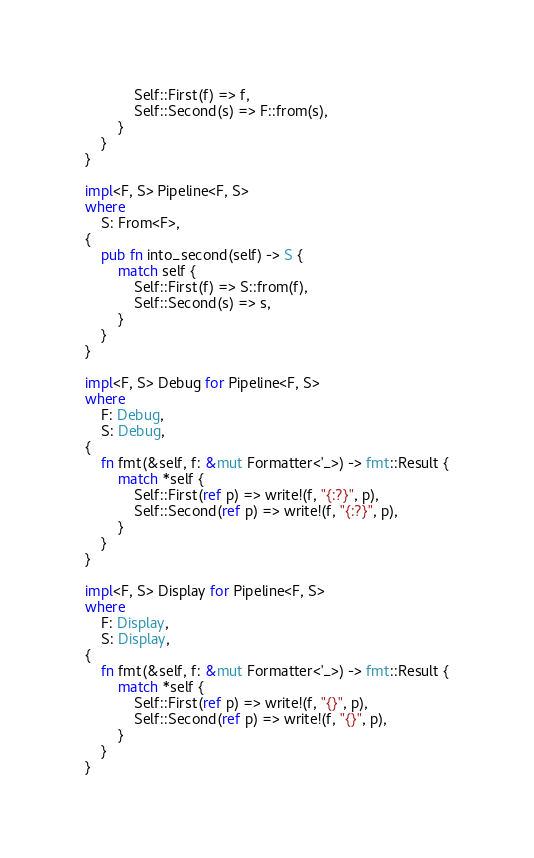<code> <loc_0><loc_0><loc_500><loc_500><_Rust_>            Self::First(f) => f,
            Self::Second(s) => F::from(s),
        }
    }
}

impl<F, S> Pipeline<F, S>
where
    S: From<F>,
{
    pub fn into_second(self) -> S {
        match self {
            Self::First(f) => S::from(f),
            Self::Second(s) => s,
        }
    }
}

impl<F, S> Debug for Pipeline<F, S>
where
    F: Debug,
    S: Debug,
{
    fn fmt(&self, f: &mut Formatter<'_>) -> fmt::Result {
        match *self {
            Self::First(ref p) => write!(f, "{:?}", p),
            Self::Second(ref p) => write!(f, "{:?}", p),
        }
    }
}

impl<F, S> Display for Pipeline<F, S>
where
    F: Display,
    S: Display,
{
    fn fmt(&self, f: &mut Formatter<'_>) -> fmt::Result {
        match *self {
            Self::First(ref p) => write!(f, "{}", p),
            Self::Second(ref p) => write!(f, "{}", p),
        }
    }
}
</code> 